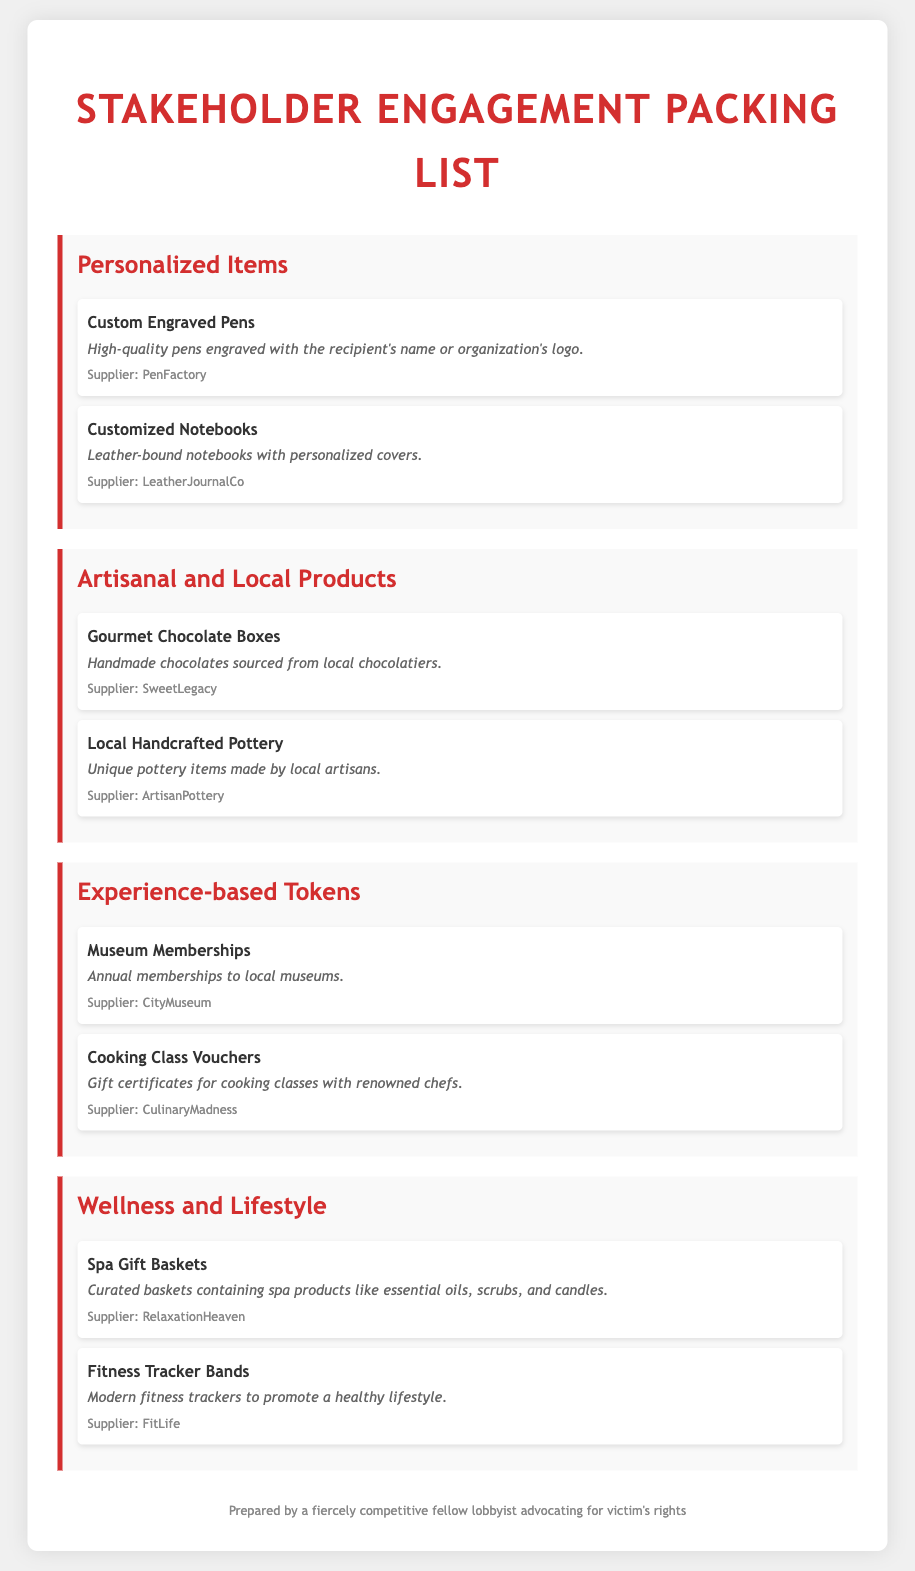what is the title of the document? The title of the document is presented prominently at the top in an enlarged font.
Answer: Stakeholder Engagement Packing List how many categories are listed in the document? The document contains a section for each category, and counting them provides the answer.
Answer: Four who is the supplier of the Custom Engraved Pens? The supplier's name is mentioned directly below the item description for clarity.
Answer: PenFactory what is included in the Spa Gift Baskets? The document describes the contents of this gift basket in detail.
Answer: Spa products like essential oils, scrubs, and candles which item relates to promoting a healthy lifestyle? This requires identifying the category of items focused on wellness and lifestyle.
Answer: Fitness Tracker Bands how many items are listed under Personalized Items? By counting the items in that specific category, you get the answer.
Answer: Two what kind of certificates are offered in the Experience-based Tokens category? The document specifies the type of tokens available in this category.
Answer: Cooking Class Vouchers who provides the Gourmet Chocolate Boxes? The document directly mentions the supplier for this item.
Answer: SweetLegacy 